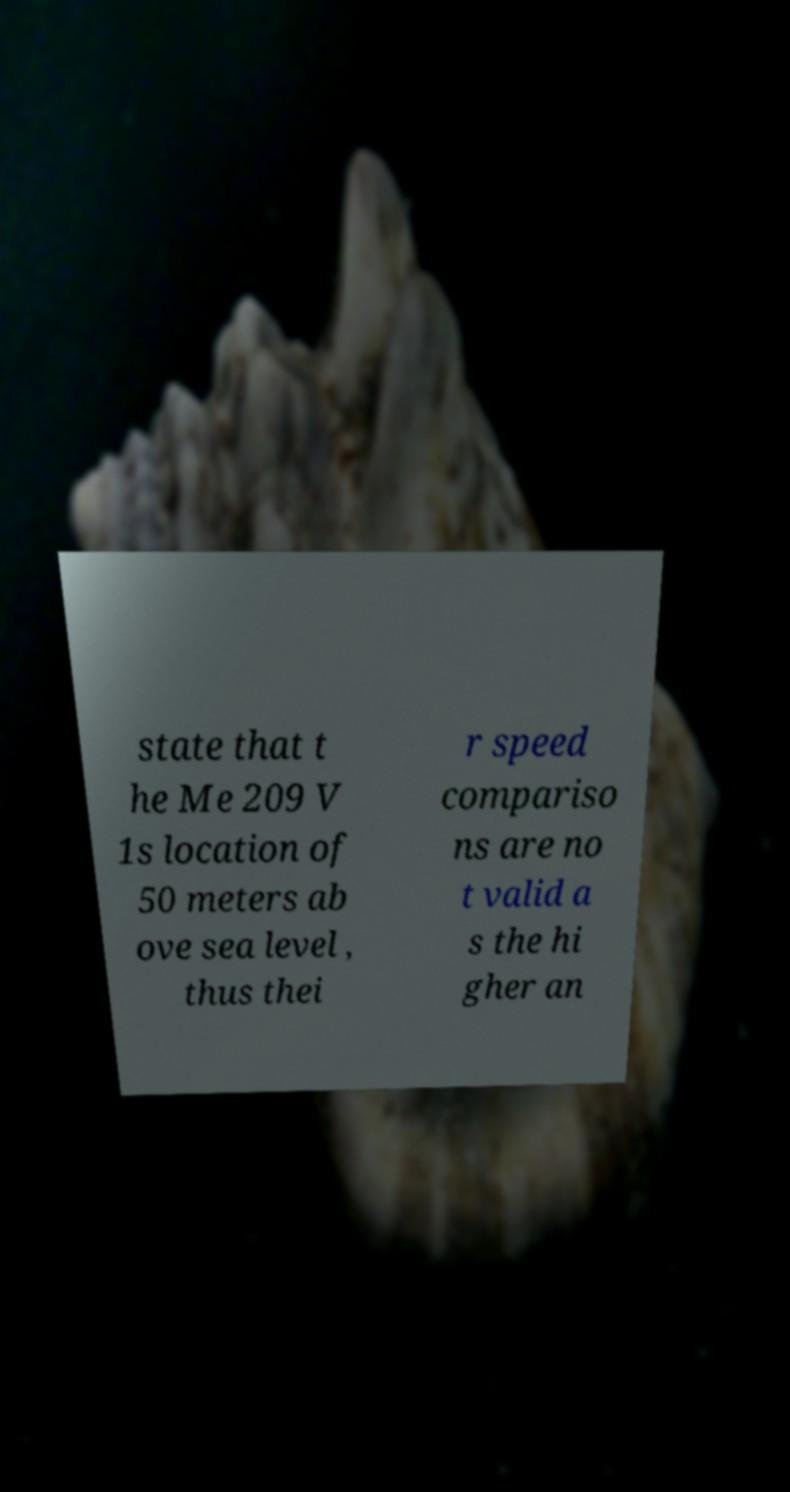For documentation purposes, I need the text within this image transcribed. Could you provide that? state that t he Me 209 V 1s location of 50 meters ab ove sea level , thus thei r speed compariso ns are no t valid a s the hi gher an 